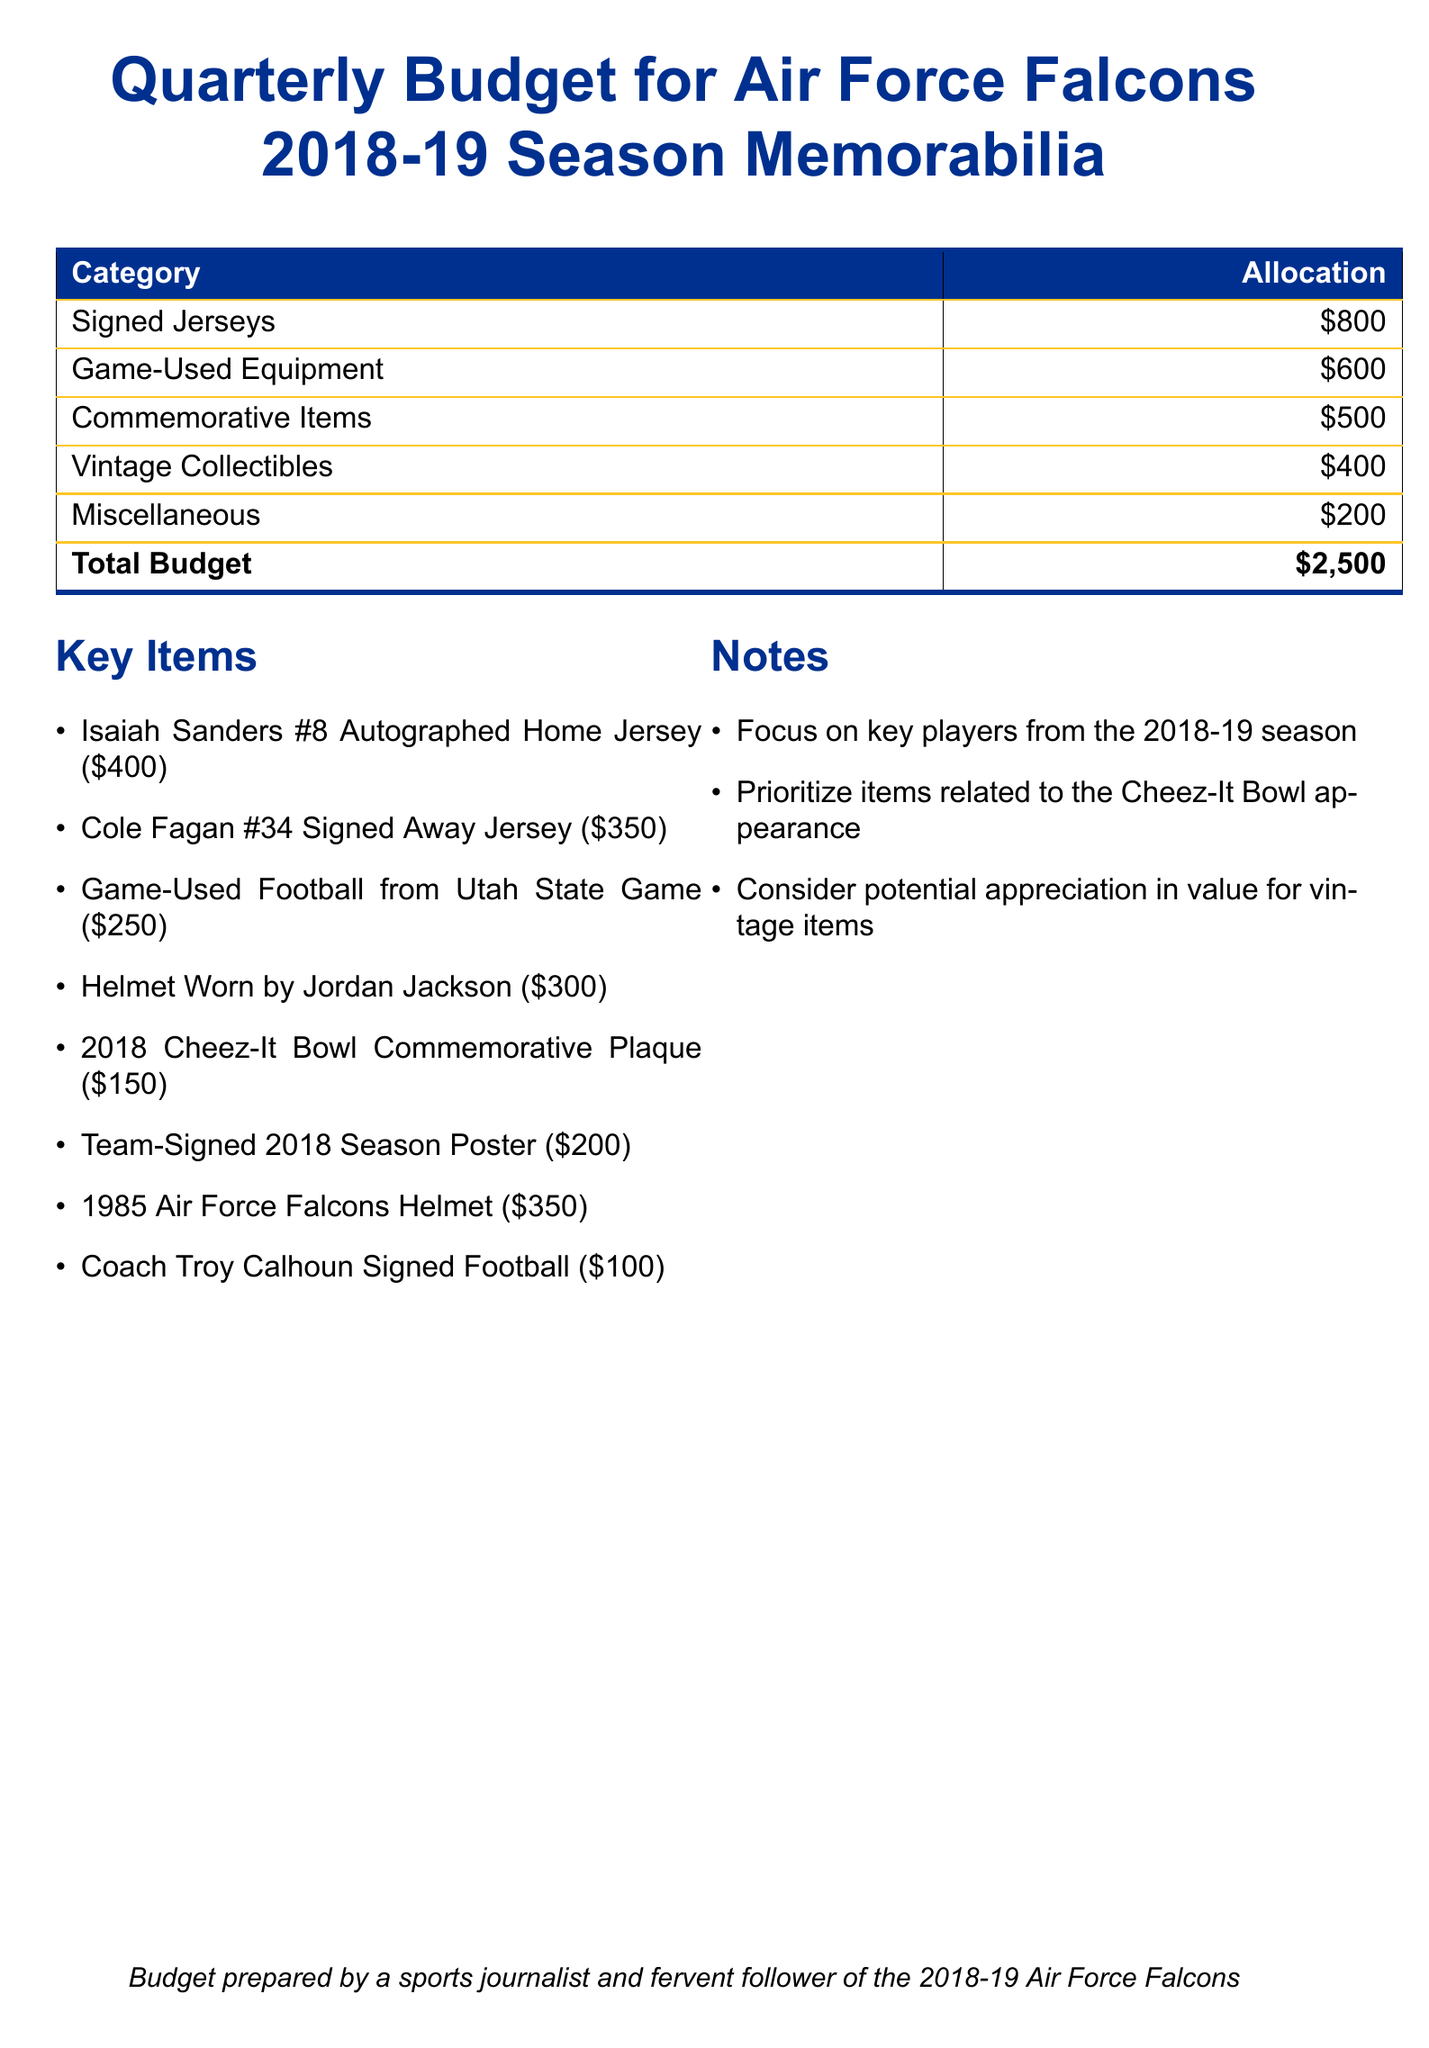What is the total budget? The total budget is directly stated in the budget table at the bottom, which sums up all allocations.
Answer: $2,500 How much is allocated for signed jerseys? The allocation for signed jerseys is specified in the document in the budget table.
Answer: $800 What item costs $300? The item that costs $300 is listed under the key items section.
Answer: Helmet Worn by Jordan Jackson Which commemorative item costs $150? The specific commemorative item cost is mentioned in the key items section.
Answer: 2018 Cheez-It Bowl Commemorative Plaque What is one focus area mentioned in the notes? The notes section highlights areas of focus that are relevant to the acquisition of memorabilia.
Answer: Key players from the 2018-19 season How much is allocated for miscellaneous items? The allocation for miscellaneous items can be found in the budget table.
Answer: $200 What percentage of the total budget is allocated to game-used equipment? This requires calculating the proportion of the game-used equipment allocation relative to the total budget.
Answer: 24% Name one player's signed item listed in the key items. The key items section lists several items, including signed jerseys and collectibles.
Answer: Isaiah Sanders #8 Autographed Home Jersey Which item is associated with the Cheez-It Bowl? The connection to the Cheez-It Bowl is explicitly mentioned in the key items section.
Answer: 2018 Cheez-It Bowl Commemorative Plaque 